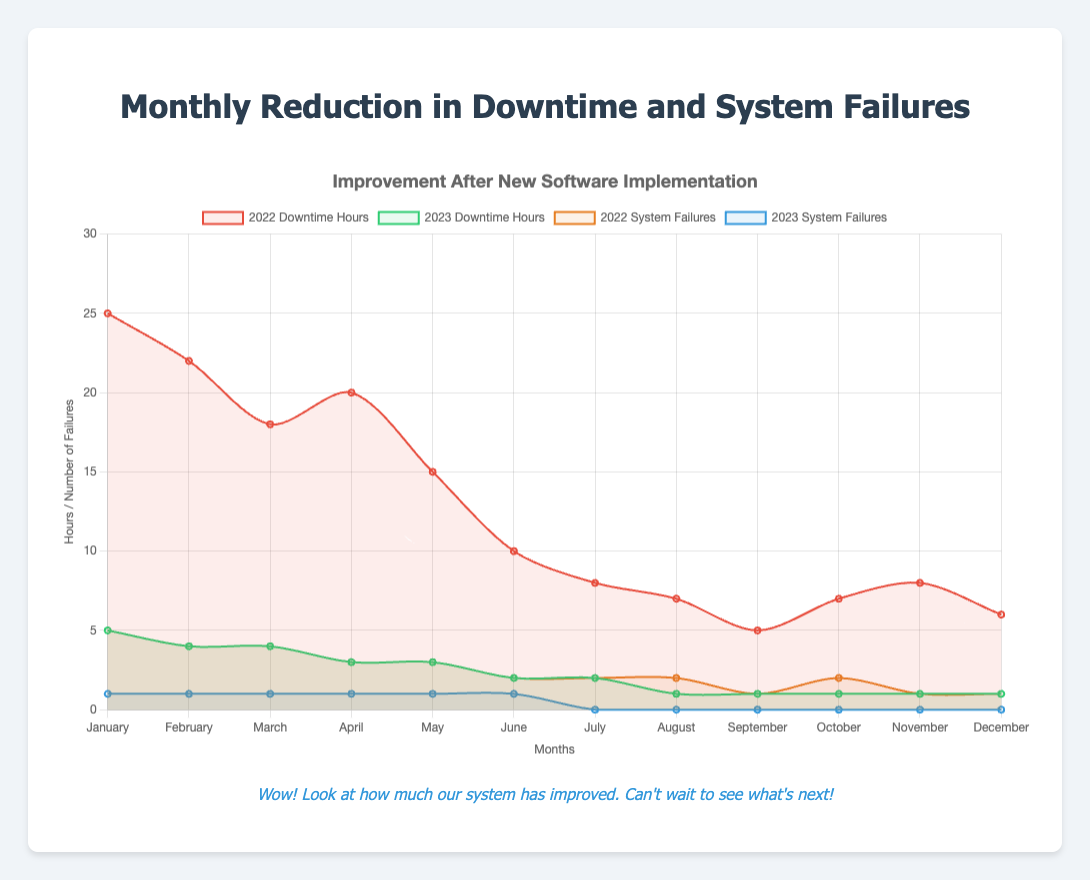Which month in 2023 had the lowest downtime hours? The plot shows the downtime hours for each month in 2023. We need to find the lowest point on the green line for 2023, which occurs in August, September, October, November, and December, all with 1 hour.
Answer: August, September, October, November, December How many total system failures occurred in 2022? To find the total number of system failures in 2022, sum the values of the orange line for each month: 5 + 4 + 4 + 3 + 3 + 2 + 2 + 2 + 1 + 2 + 1 + 1 = 30.
Answer: 30 What is the difference in downtime hours between January 2022 and January 2023? Look at the downtime hours for January 2022 and January 2023 on their respective lines. January 2022 shows 25 hours, and January 2023 shows 5 hours. The difference is obtained by subtracting 5 from 25, which is 20 hours.
Answer: 20 hours Which year had a greater reduction in downtime hours from January to December? Compare the decrease in downtime hours by finding the difference for each year from January to December. For 2022, the difference is 25 - 6 = 19. For 2023, the difference is 5 - 1 = 4. Therefore, 2022 had a greater reduction.
Answer: 2022 What was the trend in system failures in 2023? Observing the blue line for 2023 system failures, the trend decreases over time from 1 failure in the first six months to 0 failures in the last six months.
Answer: Decreasing trend In which months did the system failures drop to zero in 2023? Check the blue line for 2023 system failures and identify the month where it first reaches 0. This happens in July and continues through the rest of the year.
Answer: July By how many hours did downtime decrease between June 2022 and June 2023? Look at the downtime hours for June in both years: June 2022 shows 10 hours and June 2023 shows 2 hours. The difference is 10 - 2 = 8 hours.
Answer: 8 hours How does the frequency of system failures in March 2022 compare to March 2023? Compare the values of system failures in March for both years by looking at orange and blue lines. March 2022 had 4 failures, and March 2023 had 1 failure. March 2023 had fewer failures.
Answer: Fewer in 2023 What was the average monthly downtime hours in 2023? Sum the downtime hours across all months in 2023 and divide by 12. The total is 5 + 4 + 4 + 3 + 3 + 2 + 2 + 1 + 1 + 1 + 1 + 1 = 28. The average is 28 / 12.
Answer: 2.33 hours 